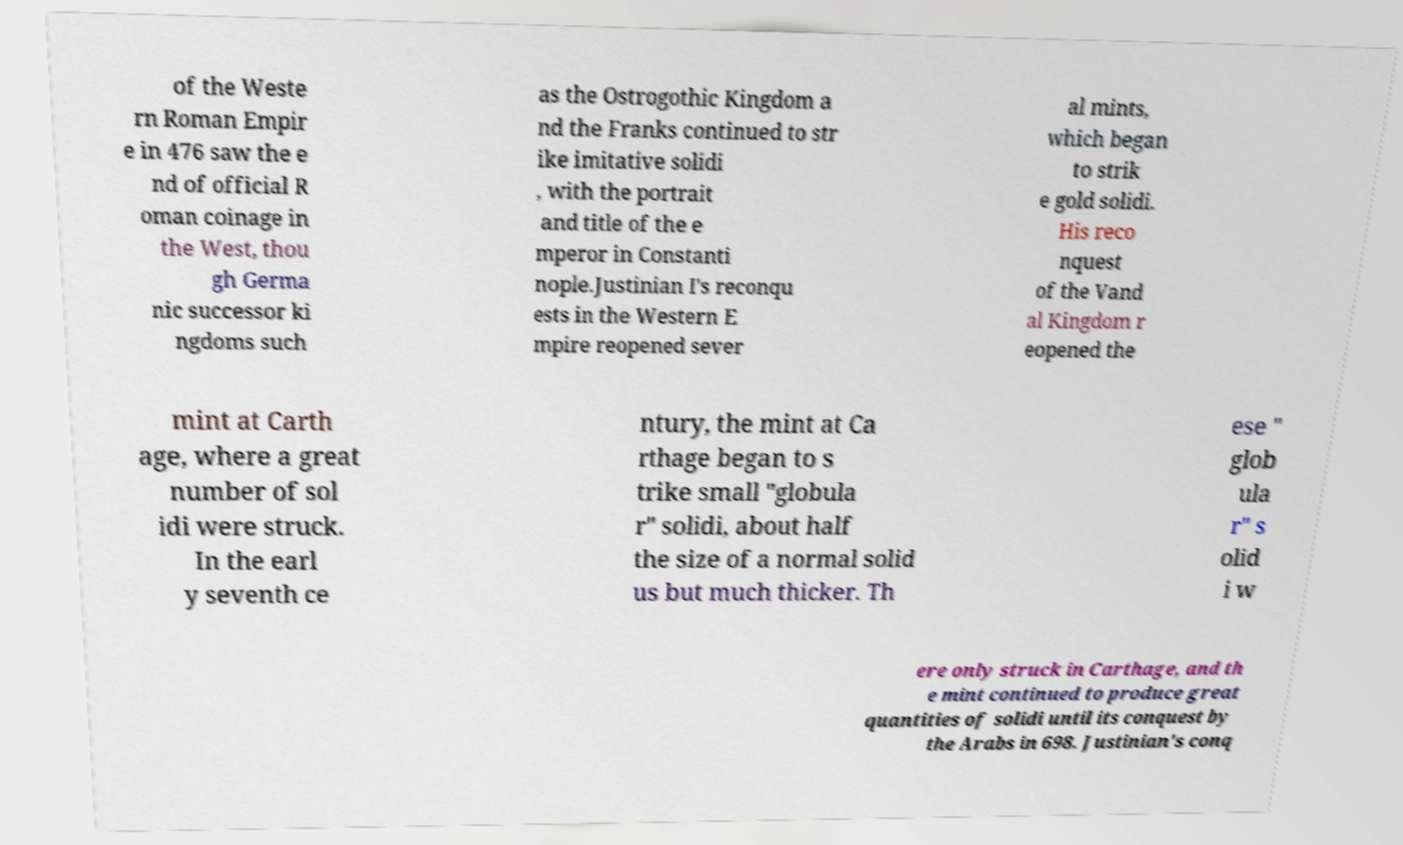Please read and relay the text visible in this image. What does it say? of the Weste rn Roman Empir e in 476 saw the e nd of official R oman coinage in the West, thou gh Germa nic successor ki ngdoms such as the Ostrogothic Kingdom a nd the Franks continued to str ike imitative solidi , with the portrait and title of the e mperor in Constanti nople.Justinian I's reconqu ests in the Western E mpire reopened sever al mints, which began to strik e gold solidi. His reco nquest of the Vand al Kingdom r eopened the mint at Carth age, where a great number of sol idi were struck. In the earl y seventh ce ntury, the mint at Ca rthage began to s trike small "globula r" solidi, about half the size of a normal solid us but much thicker. Th ese " glob ula r" s olid i w ere only struck in Carthage, and th e mint continued to produce great quantities of solidi until its conquest by the Arabs in 698. Justinian's conq 